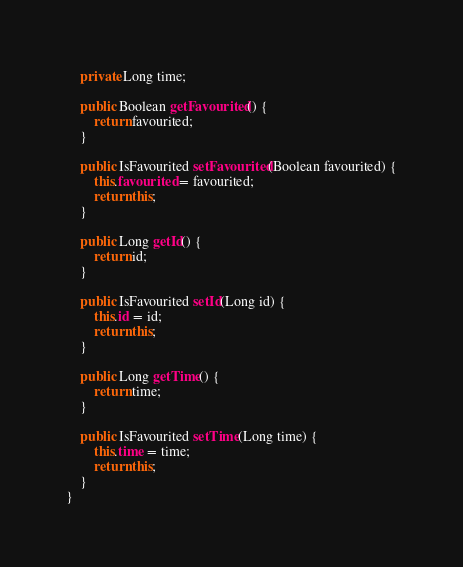Convert code to text. <code><loc_0><loc_0><loc_500><loc_500><_Java_>    private Long time;

    public Boolean getFavourited() {
        return favourited;
    }

    public IsFavourited setFavourited(Boolean favourited) {
        this.favourited = favourited;
        return this;
    }

    public Long getId() {
        return id;
    }

    public IsFavourited setId(Long id) {
        this.id = id;
        return this;
    }

    public Long getTime() {
        return time;
    }

    public IsFavourited setTime(Long time) {
        this.time = time;
        return this;
    }
}
</code> 